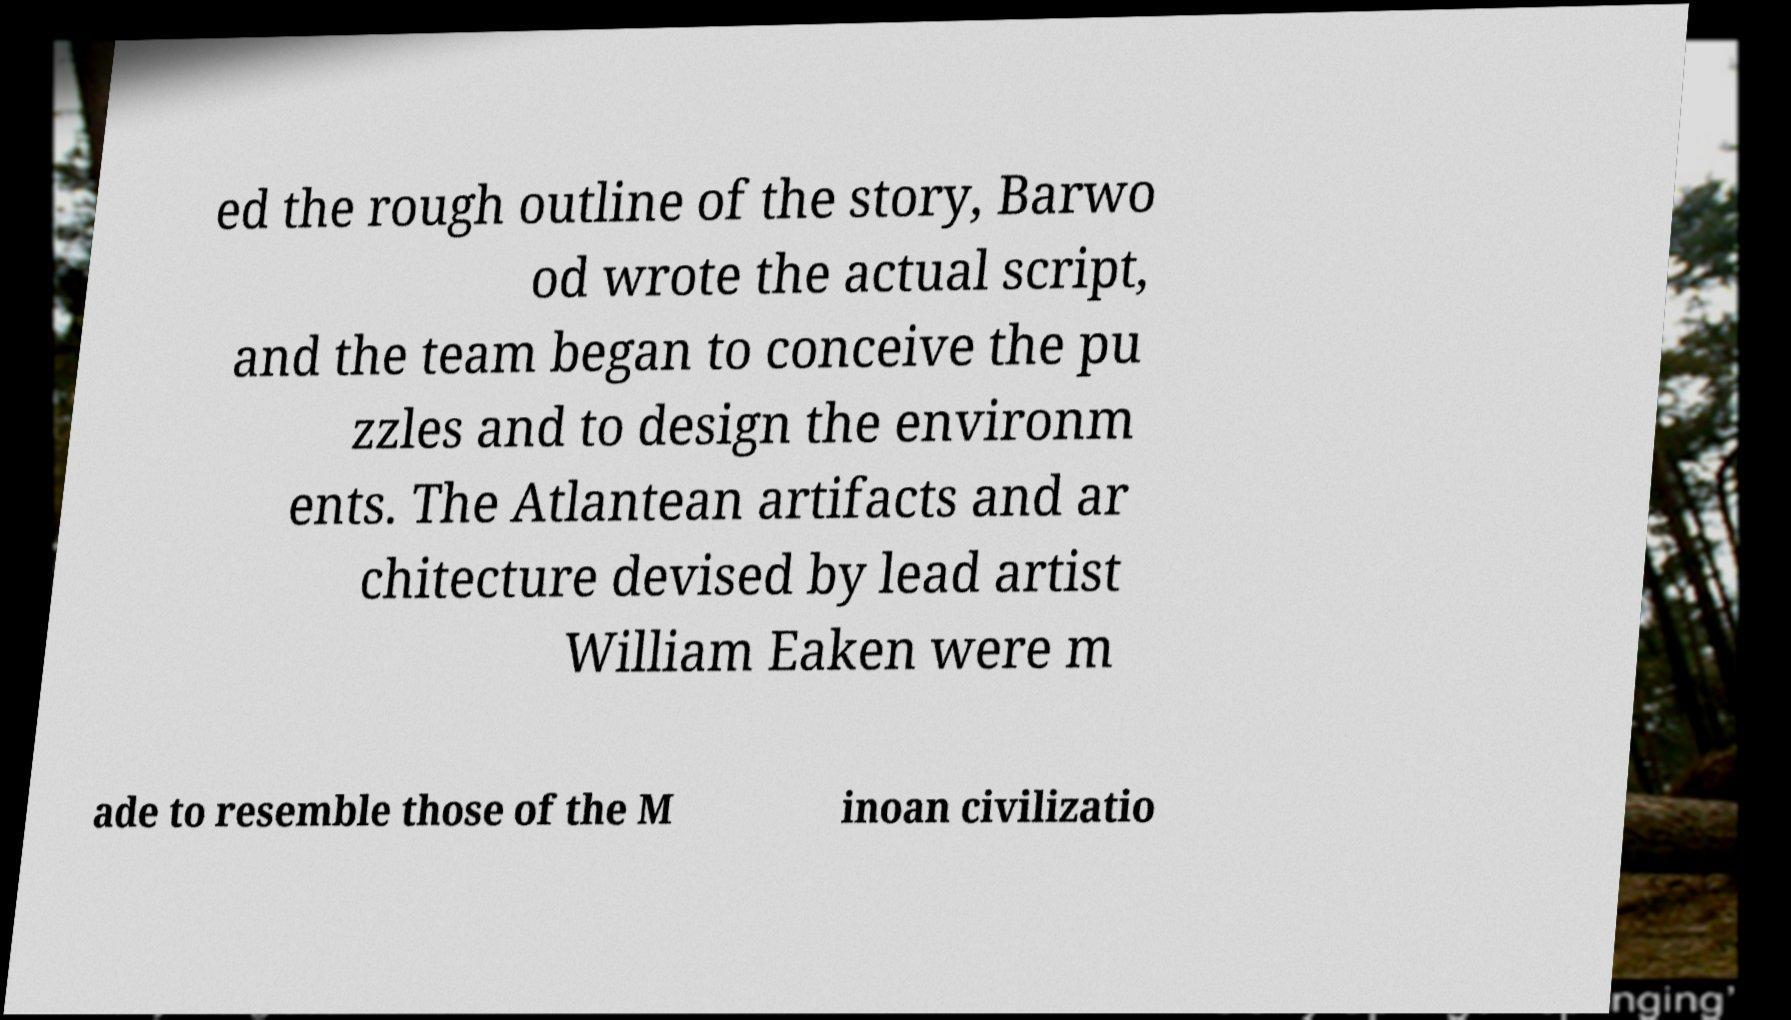Please read and relay the text visible in this image. What does it say? ed the rough outline of the story, Barwo od wrote the actual script, and the team began to conceive the pu zzles and to design the environm ents. The Atlantean artifacts and ar chitecture devised by lead artist William Eaken were m ade to resemble those of the M inoan civilizatio 